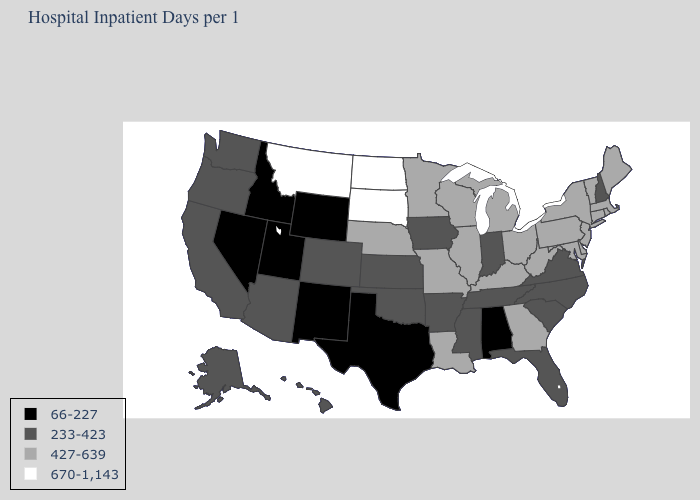Name the states that have a value in the range 427-639?
Answer briefly. Connecticut, Delaware, Georgia, Illinois, Kentucky, Louisiana, Maine, Maryland, Massachusetts, Michigan, Minnesota, Missouri, Nebraska, New Jersey, New York, Ohio, Pennsylvania, Rhode Island, Vermont, West Virginia, Wisconsin. Among the states that border Massachusetts , which have the lowest value?
Answer briefly. New Hampshire. Name the states that have a value in the range 66-227?
Write a very short answer. Alabama, Idaho, Nevada, New Mexico, Texas, Utah, Wyoming. Does New Hampshire have the highest value in the Northeast?
Answer briefly. No. What is the value of New Jersey?
Give a very brief answer. 427-639. Which states have the highest value in the USA?
Concise answer only. Montana, North Dakota, South Dakota. Among the states that border Vermont , does New York have the highest value?
Quick response, please. Yes. Among the states that border Arizona , which have the highest value?
Write a very short answer. California, Colorado. Does New Jersey have a higher value than New York?
Answer briefly. No. What is the value of Vermont?
Be succinct. 427-639. What is the highest value in the South ?
Answer briefly. 427-639. Does Texas have the lowest value in the South?
Answer briefly. Yes. What is the value of Missouri?
Give a very brief answer. 427-639. Name the states that have a value in the range 670-1,143?
Keep it brief. Montana, North Dakota, South Dakota. 